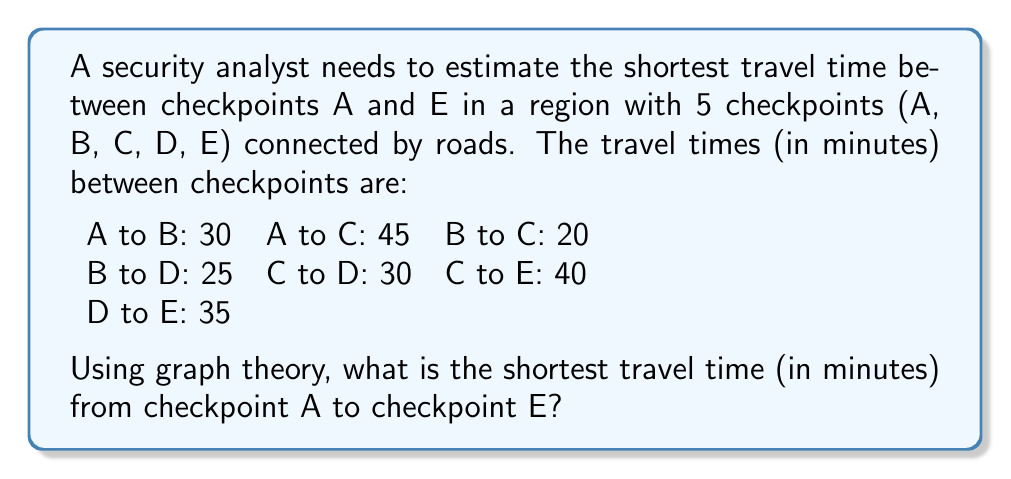Teach me how to tackle this problem. To solve this problem, we'll use Dijkstra's algorithm, a graph theory technique for finding the shortest path in a weighted graph.

1) First, let's represent the checkpoints and roads as a graph:
   - Vertices: A, B, C, D, E
   - Edges: (A,B), (A,C), (B,C), (B,D), (C,D), (C,E), (D,E)
   - Weights: corresponding travel times

2) Initialize:
   - Set distance to A as 0, all others as infinity
   - Set all nodes as unvisited

3) For the current node (starting with A), consider all unvisited neighbors and calculate their tentative distances:
   - A to B: 30
   - A to C: 45

4) Mark A as visited. B has the smallest tentative distance, so make B the current node.

5) From B:
   - B to C: min(45, 30+20) = 50
   - B to D: 30+25 = 55

6) Mark B as visited. C has the smallest tentative distance among unvisited nodes.

7) From C:
   - C to D: min(55, 50+30) = 55
   - C to E: 50+40 = 90

8) Mark C as visited. D is next.

9) From D:
   - D to E: min(90, 55+35) = 90

10) Mark D as visited. E is last and gets marked as visited.

The shortest path from A to E is A → B → C → E, with a total time of 90 minutes.
Answer: 90 minutes 